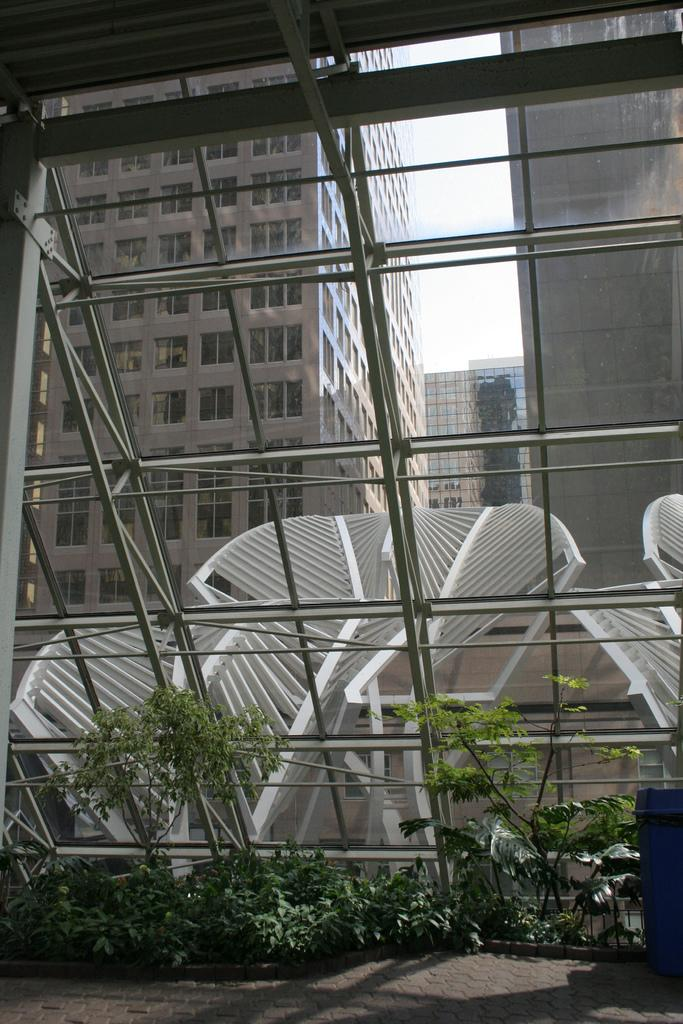What type of buildings are in the image? There are buildings in the image, but the specific type cannot be determined from the provided facts. How many windows are visible in the image? There are multiple windows visible in the image. What can be inferred about the lighting conditions in the image? Shadows are present in the image, which suggests that there is a light source casting shadows. What type of vegetation is present in the image? There are plants in the image. What type of pancake is being served in the image? There is no pancake present in the image. Can you see a snake in the image? There is no snake present in the image. 